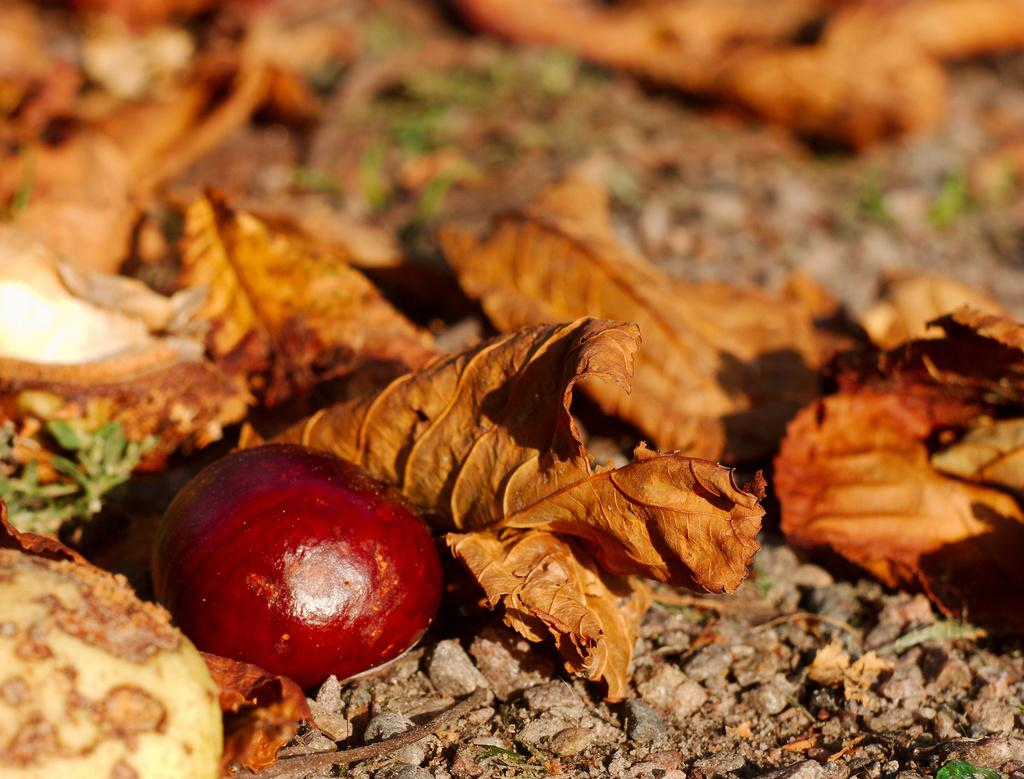What type of natural material can be seen in the image? There are dried leaves in the image. What is the color of the object on the ground? There is a red color object on the ground. What type of small objects are present on the ground? There are small stones on the ground. Can you tell me how many circles are drawn on the red object? There is no mention of circles or any drawing on the red object in the image. 